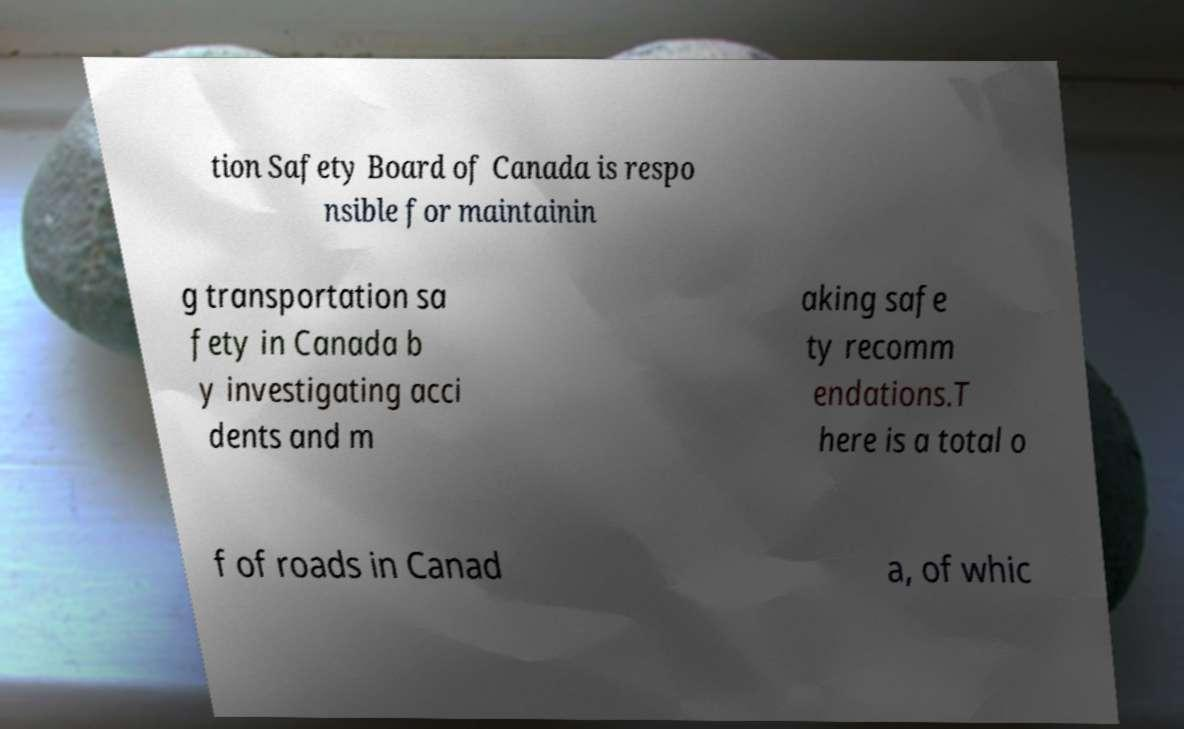Can you read and provide the text displayed in the image?This photo seems to have some interesting text. Can you extract and type it out for me? tion Safety Board of Canada is respo nsible for maintainin g transportation sa fety in Canada b y investigating acci dents and m aking safe ty recomm endations.T here is a total o f of roads in Canad a, of whic 